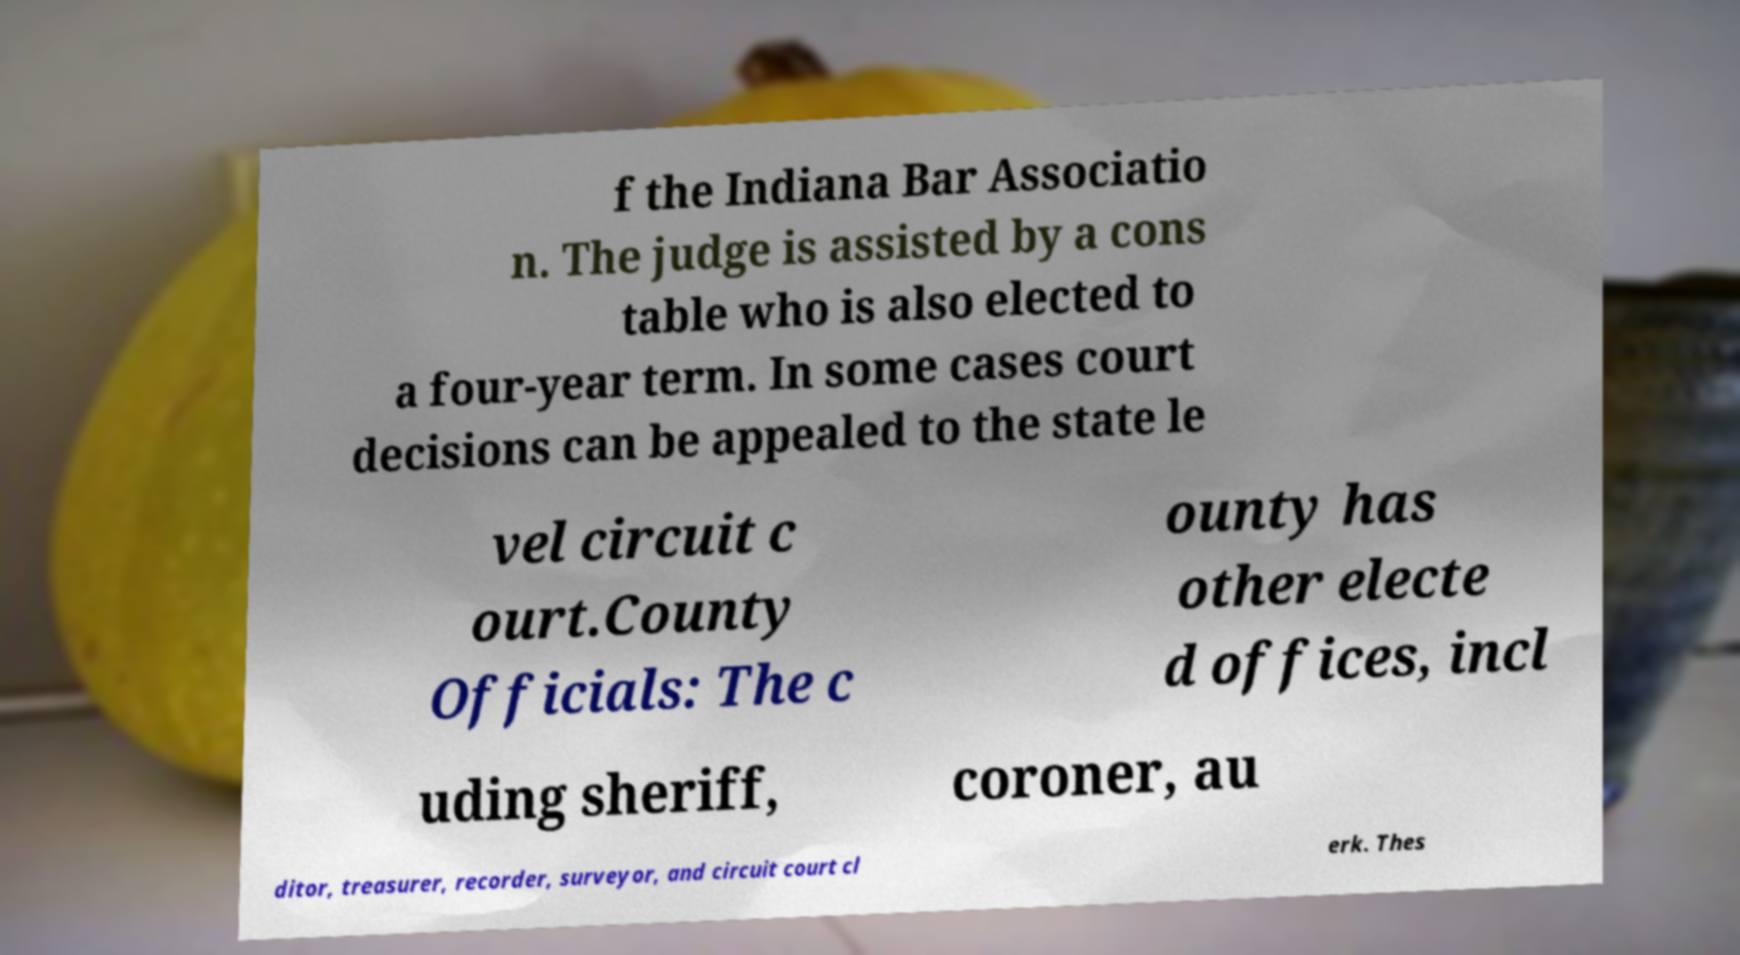For documentation purposes, I need the text within this image transcribed. Could you provide that? f the Indiana Bar Associatio n. The judge is assisted by a cons table who is also elected to a four-year term. In some cases court decisions can be appealed to the state le vel circuit c ourt.County Officials: The c ounty has other electe d offices, incl uding sheriff, coroner, au ditor, treasurer, recorder, surveyor, and circuit court cl erk. Thes 